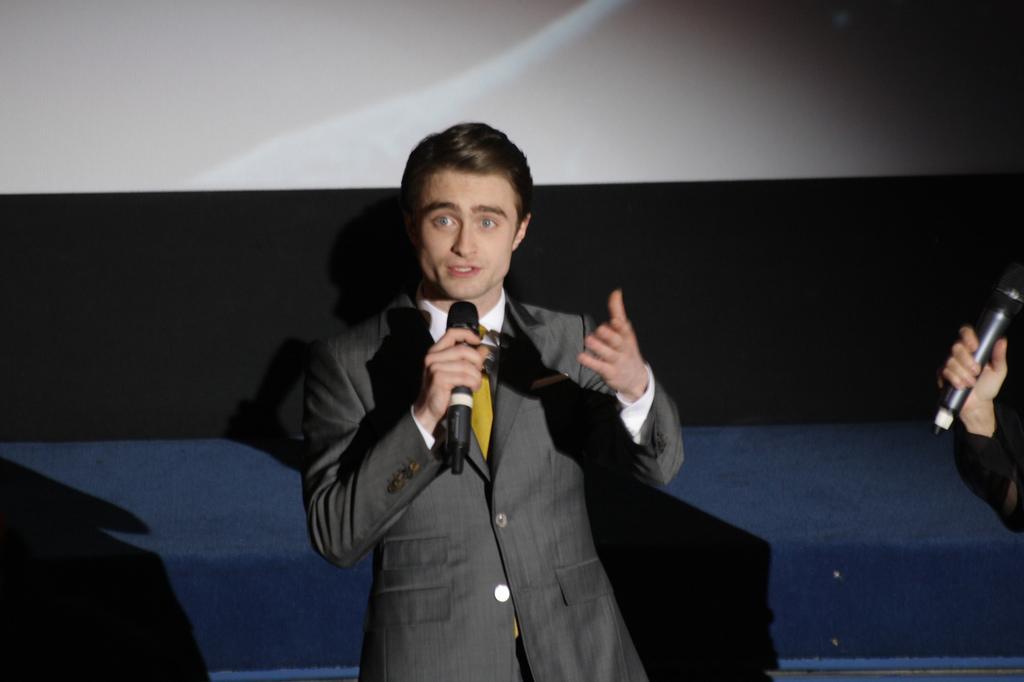Could you give a brief overview of what you see in this image? In the middle of the image a man is standing and holding microphone and talking. Bottom right side of the image a man is standing and holding a microphone. 